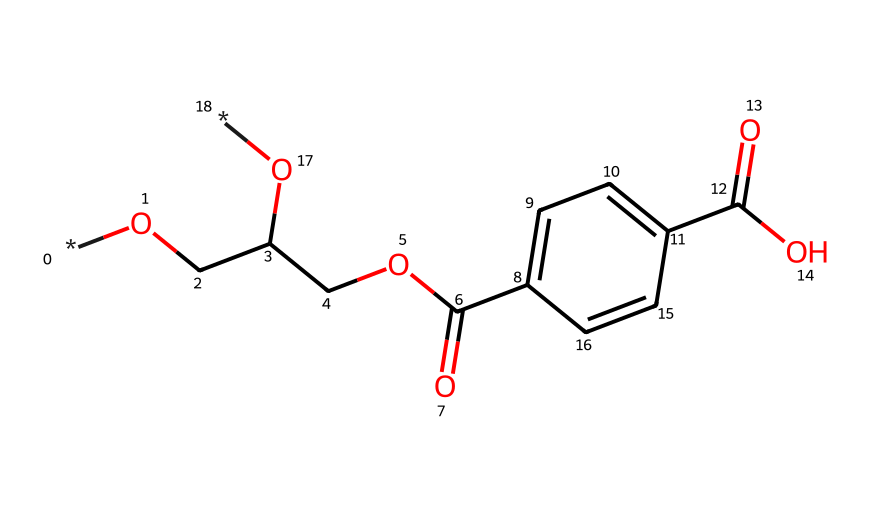What is the primary functional group present in PET? The structure contains an ester function represented by the -COO- linkages between the aromatic rings and the aliphatic chain. This feature is characteristic of polyesters like PET.
Answer: ester How many carbon atoms are there in the structure of PET? By examining the SMILES representation, you can count a total of 10 carbon atoms which are connected in various parts of the structure, including the aromatic ring and the aliphatic portion.
Answer: 10 What type of linkage is found in PET? The chemical structure features ester linkages connecting different parts of the molecule, which are indicative of polyester polymers.
Answer: ester linkages What is the main use of PET in everyday products? Given its properties such as strength and resistance to impact, PET is primarily utilized in the manufacturing of water bottles and other beverage containers.
Answer: water bottles How does the presence of phenolic rings affect the properties of PET? The phenolic rings contribute to the rigidity and thermal stability of PET, making it suitable for applications requiring structural integrity at varying temperatures.
Answer: rigidity What kind of polymerization process is used to produce PET? The production of PET typically involves a process called condensation polymerization, where monomers react to eliminate small molecules like water.
Answer: condensation polymerization 